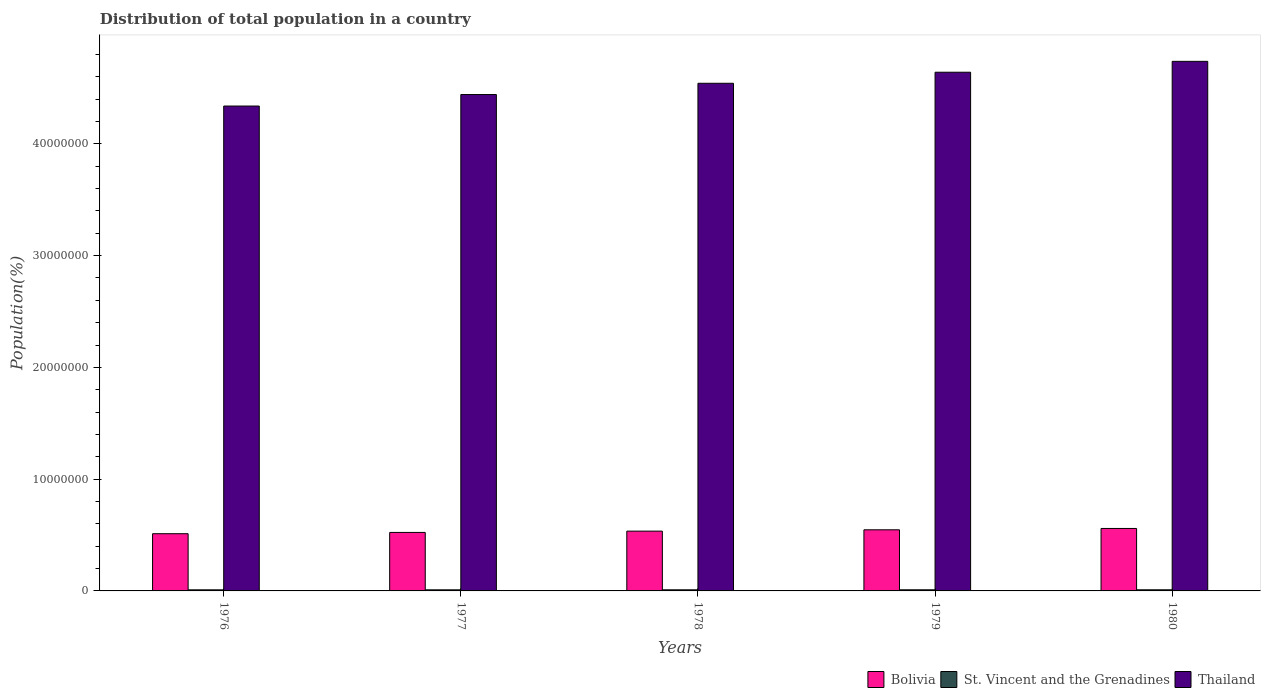Are the number of bars on each tick of the X-axis equal?
Your answer should be very brief. Yes. How many bars are there on the 1st tick from the right?
Provide a short and direct response. 3. What is the label of the 1st group of bars from the left?
Offer a very short reply. 1976. What is the population of in Thailand in 1979?
Provide a succinct answer. 4.64e+07. Across all years, what is the maximum population of in Bolivia?
Give a very brief answer. 5.59e+06. Across all years, what is the minimum population of in St. Vincent and the Grenadines?
Your answer should be compact. 9.66e+04. In which year was the population of in St. Vincent and the Grenadines minimum?
Provide a succinct answer. 1976. What is the total population of in Thailand in the graph?
Keep it short and to the point. 2.27e+08. What is the difference between the population of in Bolivia in 1977 and that in 1979?
Keep it short and to the point. -2.35e+05. What is the difference between the population of in St. Vincent and the Grenadines in 1979 and the population of in Bolivia in 1980?
Ensure brevity in your answer.  -5.49e+06. What is the average population of in Thailand per year?
Your answer should be compact. 4.54e+07. In the year 1979, what is the difference between the population of in St. Vincent and the Grenadines and population of in Bolivia?
Provide a short and direct response. -5.37e+06. What is the ratio of the population of in Thailand in 1978 to that in 1980?
Give a very brief answer. 0.96. Is the difference between the population of in St. Vincent and the Grenadines in 1976 and 1977 greater than the difference between the population of in Bolivia in 1976 and 1977?
Your response must be concise. Yes. What is the difference between the highest and the second highest population of in St. Vincent and the Grenadines?
Make the answer very short. 917. What is the difference between the highest and the lowest population of in Thailand?
Give a very brief answer. 4.00e+06. What does the 2nd bar from the left in 1980 represents?
Offer a terse response. St. Vincent and the Grenadines. Is it the case that in every year, the sum of the population of in St. Vincent and the Grenadines and population of in Bolivia is greater than the population of in Thailand?
Provide a short and direct response. No. Are all the bars in the graph horizontal?
Your response must be concise. No. How many years are there in the graph?
Make the answer very short. 5. Does the graph contain grids?
Keep it short and to the point. No. How many legend labels are there?
Your answer should be very brief. 3. What is the title of the graph?
Offer a very short reply. Distribution of total population in a country. Does "Ghana" appear as one of the legend labels in the graph?
Keep it short and to the point. No. What is the label or title of the X-axis?
Offer a terse response. Years. What is the label or title of the Y-axis?
Ensure brevity in your answer.  Population(%). What is the Population(%) in Bolivia in 1976?
Offer a terse response. 5.12e+06. What is the Population(%) in St. Vincent and the Grenadines in 1976?
Your answer should be compact. 9.66e+04. What is the Population(%) of Thailand in 1976?
Give a very brief answer. 4.34e+07. What is the Population(%) of Bolivia in 1977?
Provide a succinct answer. 5.23e+06. What is the Population(%) of St. Vincent and the Grenadines in 1977?
Make the answer very short. 9.76e+04. What is the Population(%) of Thailand in 1977?
Your response must be concise. 4.44e+07. What is the Population(%) in Bolivia in 1978?
Your answer should be compact. 5.35e+06. What is the Population(%) in St. Vincent and the Grenadines in 1978?
Give a very brief answer. 9.86e+04. What is the Population(%) of Thailand in 1978?
Make the answer very short. 4.54e+07. What is the Population(%) of Bolivia in 1979?
Ensure brevity in your answer.  5.47e+06. What is the Population(%) of St. Vincent and the Grenadines in 1979?
Keep it short and to the point. 9.96e+04. What is the Population(%) in Thailand in 1979?
Your answer should be very brief. 4.64e+07. What is the Population(%) in Bolivia in 1980?
Offer a very short reply. 5.59e+06. What is the Population(%) in St. Vincent and the Grenadines in 1980?
Your response must be concise. 1.01e+05. What is the Population(%) of Thailand in 1980?
Provide a short and direct response. 4.74e+07. Across all years, what is the maximum Population(%) of Bolivia?
Offer a very short reply. 5.59e+06. Across all years, what is the maximum Population(%) in St. Vincent and the Grenadines?
Your answer should be compact. 1.01e+05. Across all years, what is the maximum Population(%) in Thailand?
Your response must be concise. 4.74e+07. Across all years, what is the minimum Population(%) of Bolivia?
Your answer should be compact. 5.12e+06. Across all years, what is the minimum Population(%) in St. Vincent and the Grenadines?
Your answer should be compact. 9.66e+04. Across all years, what is the minimum Population(%) in Thailand?
Offer a very short reply. 4.34e+07. What is the total Population(%) in Bolivia in the graph?
Your answer should be compact. 2.68e+07. What is the total Population(%) in St. Vincent and the Grenadines in the graph?
Offer a terse response. 4.93e+05. What is the total Population(%) of Thailand in the graph?
Offer a terse response. 2.27e+08. What is the difference between the Population(%) of Bolivia in 1976 and that in 1977?
Make the answer very short. -1.14e+05. What is the difference between the Population(%) in St. Vincent and the Grenadines in 1976 and that in 1977?
Give a very brief answer. -1010. What is the difference between the Population(%) of Thailand in 1976 and that in 1977?
Your answer should be compact. -1.03e+06. What is the difference between the Population(%) of Bolivia in 1976 and that in 1978?
Offer a very short reply. -2.30e+05. What is the difference between the Population(%) of St. Vincent and the Grenadines in 1976 and that in 1978?
Your answer should be compact. -1995. What is the difference between the Population(%) in Thailand in 1976 and that in 1978?
Offer a terse response. -2.04e+06. What is the difference between the Population(%) of Bolivia in 1976 and that in 1979?
Provide a short and direct response. -3.49e+05. What is the difference between the Population(%) of St. Vincent and the Grenadines in 1976 and that in 1979?
Provide a succinct answer. -2950. What is the difference between the Population(%) in Thailand in 1976 and that in 1979?
Your answer should be very brief. -3.03e+06. What is the difference between the Population(%) of Bolivia in 1976 and that in 1980?
Your answer should be very brief. -4.70e+05. What is the difference between the Population(%) in St. Vincent and the Grenadines in 1976 and that in 1980?
Keep it short and to the point. -3867. What is the difference between the Population(%) of Thailand in 1976 and that in 1980?
Your answer should be compact. -4.00e+06. What is the difference between the Population(%) in Bolivia in 1977 and that in 1978?
Ensure brevity in your answer.  -1.17e+05. What is the difference between the Population(%) of St. Vincent and the Grenadines in 1977 and that in 1978?
Your response must be concise. -985. What is the difference between the Population(%) in Thailand in 1977 and that in 1978?
Offer a very short reply. -1.01e+06. What is the difference between the Population(%) in Bolivia in 1977 and that in 1979?
Provide a short and direct response. -2.35e+05. What is the difference between the Population(%) of St. Vincent and the Grenadines in 1977 and that in 1979?
Provide a succinct answer. -1940. What is the difference between the Population(%) in Thailand in 1977 and that in 1979?
Keep it short and to the point. -2.00e+06. What is the difference between the Population(%) of Bolivia in 1977 and that in 1980?
Provide a short and direct response. -3.56e+05. What is the difference between the Population(%) of St. Vincent and the Grenadines in 1977 and that in 1980?
Your response must be concise. -2857. What is the difference between the Population(%) of Thailand in 1977 and that in 1980?
Give a very brief answer. -2.97e+06. What is the difference between the Population(%) in Bolivia in 1978 and that in 1979?
Ensure brevity in your answer.  -1.19e+05. What is the difference between the Population(%) in St. Vincent and the Grenadines in 1978 and that in 1979?
Your answer should be very brief. -955. What is the difference between the Population(%) in Thailand in 1978 and that in 1979?
Offer a very short reply. -9.89e+05. What is the difference between the Population(%) of Bolivia in 1978 and that in 1980?
Give a very brief answer. -2.39e+05. What is the difference between the Population(%) in St. Vincent and the Grenadines in 1978 and that in 1980?
Your answer should be compact. -1872. What is the difference between the Population(%) of Thailand in 1978 and that in 1980?
Keep it short and to the point. -1.96e+06. What is the difference between the Population(%) in Bolivia in 1979 and that in 1980?
Your response must be concise. -1.20e+05. What is the difference between the Population(%) of St. Vincent and the Grenadines in 1979 and that in 1980?
Offer a terse response. -917. What is the difference between the Population(%) in Thailand in 1979 and that in 1980?
Ensure brevity in your answer.  -9.73e+05. What is the difference between the Population(%) of Bolivia in 1976 and the Population(%) of St. Vincent and the Grenadines in 1977?
Provide a short and direct response. 5.02e+06. What is the difference between the Population(%) in Bolivia in 1976 and the Population(%) in Thailand in 1977?
Provide a short and direct response. -3.93e+07. What is the difference between the Population(%) in St. Vincent and the Grenadines in 1976 and the Population(%) in Thailand in 1977?
Ensure brevity in your answer.  -4.43e+07. What is the difference between the Population(%) in Bolivia in 1976 and the Population(%) in St. Vincent and the Grenadines in 1978?
Offer a terse response. 5.02e+06. What is the difference between the Population(%) in Bolivia in 1976 and the Population(%) in Thailand in 1978?
Keep it short and to the point. -4.03e+07. What is the difference between the Population(%) in St. Vincent and the Grenadines in 1976 and the Population(%) in Thailand in 1978?
Provide a short and direct response. -4.53e+07. What is the difference between the Population(%) of Bolivia in 1976 and the Population(%) of St. Vincent and the Grenadines in 1979?
Your answer should be very brief. 5.02e+06. What is the difference between the Population(%) in Bolivia in 1976 and the Population(%) in Thailand in 1979?
Your answer should be very brief. -4.13e+07. What is the difference between the Population(%) in St. Vincent and the Grenadines in 1976 and the Population(%) in Thailand in 1979?
Keep it short and to the point. -4.63e+07. What is the difference between the Population(%) in Bolivia in 1976 and the Population(%) in St. Vincent and the Grenadines in 1980?
Provide a short and direct response. 5.02e+06. What is the difference between the Population(%) in Bolivia in 1976 and the Population(%) in Thailand in 1980?
Provide a short and direct response. -4.23e+07. What is the difference between the Population(%) of St. Vincent and the Grenadines in 1976 and the Population(%) of Thailand in 1980?
Keep it short and to the point. -4.73e+07. What is the difference between the Population(%) in Bolivia in 1977 and the Population(%) in St. Vincent and the Grenadines in 1978?
Provide a succinct answer. 5.14e+06. What is the difference between the Population(%) in Bolivia in 1977 and the Population(%) in Thailand in 1978?
Ensure brevity in your answer.  -4.02e+07. What is the difference between the Population(%) of St. Vincent and the Grenadines in 1977 and the Population(%) of Thailand in 1978?
Provide a succinct answer. -4.53e+07. What is the difference between the Population(%) of Bolivia in 1977 and the Population(%) of St. Vincent and the Grenadines in 1979?
Keep it short and to the point. 5.13e+06. What is the difference between the Population(%) of Bolivia in 1977 and the Population(%) of Thailand in 1979?
Provide a succinct answer. -4.12e+07. What is the difference between the Population(%) in St. Vincent and the Grenadines in 1977 and the Population(%) in Thailand in 1979?
Keep it short and to the point. -4.63e+07. What is the difference between the Population(%) in Bolivia in 1977 and the Population(%) in St. Vincent and the Grenadines in 1980?
Make the answer very short. 5.13e+06. What is the difference between the Population(%) in Bolivia in 1977 and the Population(%) in Thailand in 1980?
Give a very brief answer. -4.22e+07. What is the difference between the Population(%) of St. Vincent and the Grenadines in 1977 and the Population(%) of Thailand in 1980?
Give a very brief answer. -4.73e+07. What is the difference between the Population(%) of Bolivia in 1978 and the Population(%) of St. Vincent and the Grenadines in 1979?
Make the answer very short. 5.25e+06. What is the difference between the Population(%) in Bolivia in 1978 and the Population(%) in Thailand in 1979?
Offer a very short reply. -4.11e+07. What is the difference between the Population(%) of St. Vincent and the Grenadines in 1978 and the Population(%) of Thailand in 1979?
Your answer should be very brief. -4.63e+07. What is the difference between the Population(%) in Bolivia in 1978 and the Population(%) in St. Vincent and the Grenadines in 1980?
Offer a terse response. 5.25e+06. What is the difference between the Population(%) in Bolivia in 1978 and the Population(%) in Thailand in 1980?
Offer a very short reply. -4.20e+07. What is the difference between the Population(%) of St. Vincent and the Grenadines in 1978 and the Population(%) of Thailand in 1980?
Provide a succinct answer. -4.73e+07. What is the difference between the Population(%) of Bolivia in 1979 and the Population(%) of St. Vincent and the Grenadines in 1980?
Your response must be concise. 5.37e+06. What is the difference between the Population(%) in Bolivia in 1979 and the Population(%) in Thailand in 1980?
Provide a short and direct response. -4.19e+07. What is the difference between the Population(%) in St. Vincent and the Grenadines in 1979 and the Population(%) in Thailand in 1980?
Your answer should be very brief. -4.73e+07. What is the average Population(%) in Bolivia per year?
Keep it short and to the point. 5.35e+06. What is the average Population(%) of St. Vincent and the Grenadines per year?
Your answer should be compact. 9.86e+04. What is the average Population(%) in Thailand per year?
Offer a terse response. 4.54e+07. In the year 1976, what is the difference between the Population(%) of Bolivia and Population(%) of St. Vincent and the Grenadines?
Provide a succinct answer. 5.02e+06. In the year 1976, what is the difference between the Population(%) in Bolivia and Population(%) in Thailand?
Offer a terse response. -3.83e+07. In the year 1976, what is the difference between the Population(%) of St. Vincent and the Grenadines and Population(%) of Thailand?
Keep it short and to the point. -4.33e+07. In the year 1977, what is the difference between the Population(%) in Bolivia and Population(%) in St. Vincent and the Grenadines?
Provide a short and direct response. 5.14e+06. In the year 1977, what is the difference between the Population(%) in Bolivia and Population(%) in Thailand?
Your answer should be very brief. -3.92e+07. In the year 1977, what is the difference between the Population(%) of St. Vincent and the Grenadines and Population(%) of Thailand?
Offer a terse response. -4.43e+07. In the year 1978, what is the difference between the Population(%) in Bolivia and Population(%) in St. Vincent and the Grenadines?
Provide a short and direct response. 5.25e+06. In the year 1978, what is the difference between the Population(%) of Bolivia and Population(%) of Thailand?
Your answer should be compact. -4.01e+07. In the year 1978, what is the difference between the Population(%) in St. Vincent and the Grenadines and Population(%) in Thailand?
Make the answer very short. -4.53e+07. In the year 1979, what is the difference between the Population(%) of Bolivia and Population(%) of St. Vincent and the Grenadines?
Give a very brief answer. 5.37e+06. In the year 1979, what is the difference between the Population(%) in Bolivia and Population(%) in Thailand?
Provide a succinct answer. -4.09e+07. In the year 1979, what is the difference between the Population(%) in St. Vincent and the Grenadines and Population(%) in Thailand?
Your response must be concise. -4.63e+07. In the year 1980, what is the difference between the Population(%) in Bolivia and Population(%) in St. Vincent and the Grenadines?
Your response must be concise. 5.49e+06. In the year 1980, what is the difference between the Population(%) in Bolivia and Population(%) in Thailand?
Your answer should be very brief. -4.18e+07. In the year 1980, what is the difference between the Population(%) in St. Vincent and the Grenadines and Population(%) in Thailand?
Provide a succinct answer. -4.73e+07. What is the ratio of the Population(%) in Bolivia in 1976 to that in 1977?
Your response must be concise. 0.98. What is the ratio of the Population(%) of Thailand in 1976 to that in 1977?
Your answer should be very brief. 0.98. What is the ratio of the Population(%) of Bolivia in 1976 to that in 1978?
Your answer should be compact. 0.96. What is the ratio of the Population(%) of St. Vincent and the Grenadines in 1976 to that in 1978?
Offer a terse response. 0.98. What is the ratio of the Population(%) of Thailand in 1976 to that in 1978?
Keep it short and to the point. 0.96. What is the ratio of the Population(%) in Bolivia in 1976 to that in 1979?
Your answer should be compact. 0.94. What is the ratio of the Population(%) in St. Vincent and the Grenadines in 1976 to that in 1979?
Offer a very short reply. 0.97. What is the ratio of the Population(%) in Thailand in 1976 to that in 1979?
Ensure brevity in your answer.  0.93. What is the ratio of the Population(%) of Bolivia in 1976 to that in 1980?
Offer a terse response. 0.92. What is the ratio of the Population(%) in St. Vincent and the Grenadines in 1976 to that in 1980?
Your answer should be very brief. 0.96. What is the ratio of the Population(%) in Thailand in 1976 to that in 1980?
Provide a short and direct response. 0.92. What is the ratio of the Population(%) of Bolivia in 1977 to that in 1978?
Make the answer very short. 0.98. What is the ratio of the Population(%) in Thailand in 1977 to that in 1978?
Give a very brief answer. 0.98. What is the ratio of the Population(%) of Bolivia in 1977 to that in 1979?
Offer a very short reply. 0.96. What is the ratio of the Population(%) in St. Vincent and the Grenadines in 1977 to that in 1979?
Your response must be concise. 0.98. What is the ratio of the Population(%) in Thailand in 1977 to that in 1979?
Ensure brevity in your answer.  0.96. What is the ratio of the Population(%) in Bolivia in 1977 to that in 1980?
Provide a short and direct response. 0.94. What is the ratio of the Population(%) in St. Vincent and the Grenadines in 1977 to that in 1980?
Your answer should be very brief. 0.97. What is the ratio of the Population(%) in Thailand in 1977 to that in 1980?
Your answer should be compact. 0.94. What is the ratio of the Population(%) of Bolivia in 1978 to that in 1979?
Provide a short and direct response. 0.98. What is the ratio of the Population(%) of Thailand in 1978 to that in 1979?
Make the answer very short. 0.98. What is the ratio of the Population(%) in Bolivia in 1978 to that in 1980?
Your response must be concise. 0.96. What is the ratio of the Population(%) in St. Vincent and the Grenadines in 1978 to that in 1980?
Your response must be concise. 0.98. What is the ratio of the Population(%) of Thailand in 1978 to that in 1980?
Offer a terse response. 0.96. What is the ratio of the Population(%) in Bolivia in 1979 to that in 1980?
Keep it short and to the point. 0.98. What is the ratio of the Population(%) in St. Vincent and the Grenadines in 1979 to that in 1980?
Provide a short and direct response. 0.99. What is the ratio of the Population(%) in Thailand in 1979 to that in 1980?
Offer a terse response. 0.98. What is the difference between the highest and the second highest Population(%) of Bolivia?
Provide a succinct answer. 1.20e+05. What is the difference between the highest and the second highest Population(%) of St. Vincent and the Grenadines?
Offer a terse response. 917. What is the difference between the highest and the second highest Population(%) in Thailand?
Offer a very short reply. 9.73e+05. What is the difference between the highest and the lowest Population(%) of Bolivia?
Make the answer very short. 4.70e+05. What is the difference between the highest and the lowest Population(%) of St. Vincent and the Grenadines?
Offer a very short reply. 3867. What is the difference between the highest and the lowest Population(%) of Thailand?
Your answer should be very brief. 4.00e+06. 